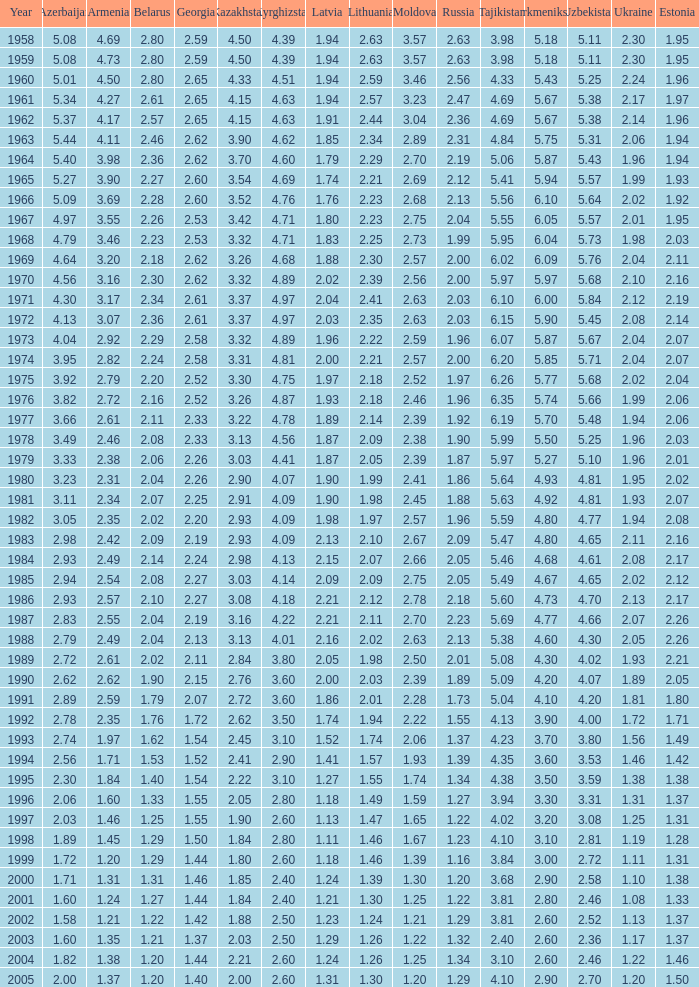Tell me the lowest kazakhstan for kyrghizstan of 4.62 and belarus less than 2.46 None. 